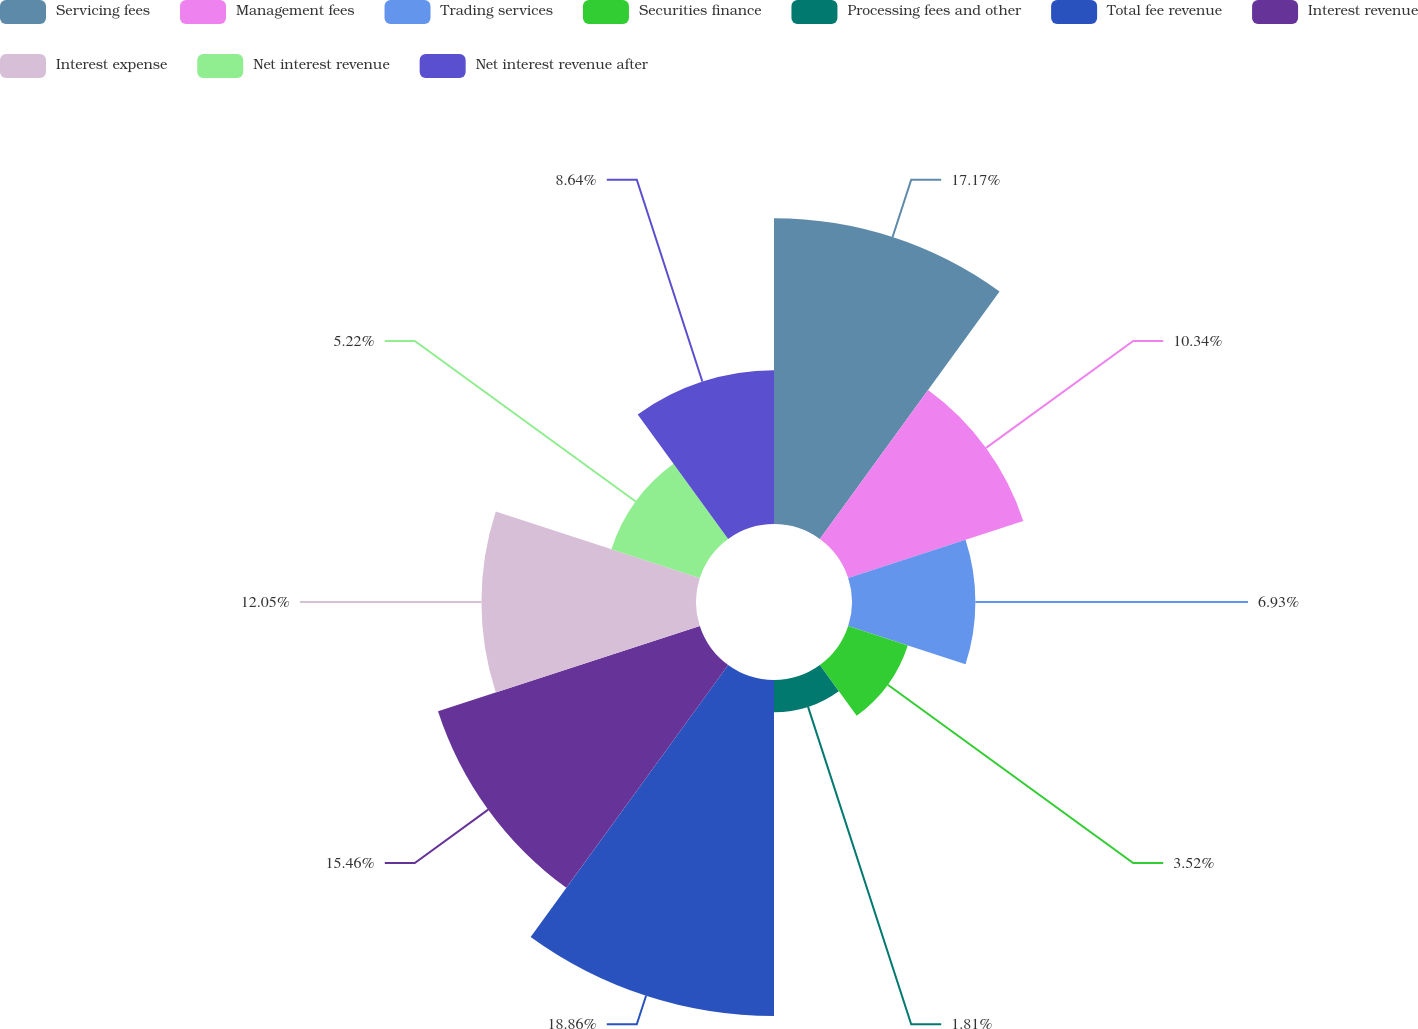Convert chart. <chart><loc_0><loc_0><loc_500><loc_500><pie_chart><fcel>Servicing fees<fcel>Management fees<fcel>Trading services<fcel>Securities finance<fcel>Processing fees and other<fcel>Total fee revenue<fcel>Interest revenue<fcel>Interest expense<fcel>Net interest revenue<fcel>Net interest revenue after<nl><fcel>17.17%<fcel>10.34%<fcel>6.93%<fcel>3.52%<fcel>1.81%<fcel>18.87%<fcel>15.46%<fcel>12.05%<fcel>5.22%<fcel>8.64%<nl></chart> 